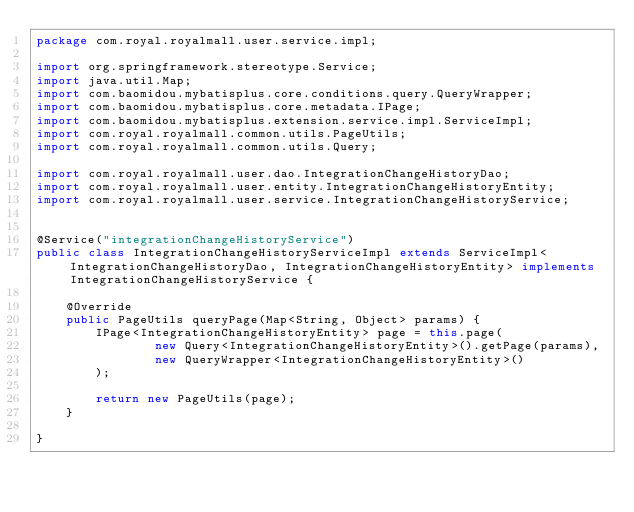Convert code to text. <code><loc_0><loc_0><loc_500><loc_500><_Java_>package com.royal.royalmall.user.service.impl;

import org.springframework.stereotype.Service;
import java.util.Map;
import com.baomidou.mybatisplus.core.conditions.query.QueryWrapper;
import com.baomidou.mybatisplus.core.metadata.IPage;
import com.baomidou.mybatisplus.extension.service.impl.ServiceImpl;
import com.royal.royalmall.common.utils.PageUtils;
import com.royal.royalmall.common.utils.Query;

import com.royal.royalmall.user.dao.IntegrationChangeHistoryDao;
import com.royal.royalmall.user.entity.IntegrationChangeHistoryEntity;
import com.royal.royalmall.user.service.IntegrationChangeHistoryService;


@Service("integrationChangeHistoryService")
public class IntegrationChangeHistoryServiceImpl extends ServiceImpl<IntegrationChangeHistoryDao, IntegrationChangeHistoryEntity> implements IntegrationChangeHistoryService {

    @Override
    public PageUtils queryPage(Map<String, Object> params) {
        IPage<IntegrationChangeHistoryEntity> page = this.page(
                new Query<IntegrationChangeHistoryEntity>().getPage(params),
                new QueryWrapper<IntegrationChangeHistoryEntity>()
        );

        return new PageUtils(page);
    }

}</code> 